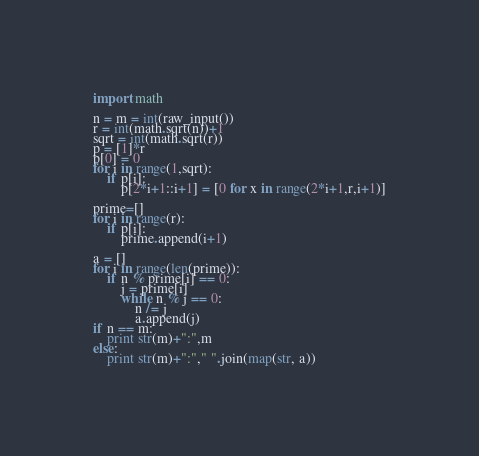<code> <loc_0><loc_0><loc_500><loc_500><_Python_>import math

n = m = int(raw_input())
r = int(math.sqrt(n))+1
sqrt = int(math.sqrt(r))
p = [1]*r
p[0] = 0
for i in range(1,sqrt):
    if p[i]:
        p[2*i+1::i+1] = [0 for x in range(2*i+1,r,i+1)]
 
prime=[]
for i in range(r):
    if p[i]:
        prime.append(i+1)

a = []
for i in range(len(prime)):
    if n % prime[i] == 0:
        j = prime[i]
        while n % j == 0:
            n /= j
            a.append(j)
if n == m:
    print str(m)+":",m
else:
    print str(m)+":"," ".join(map(str, a))</code> 